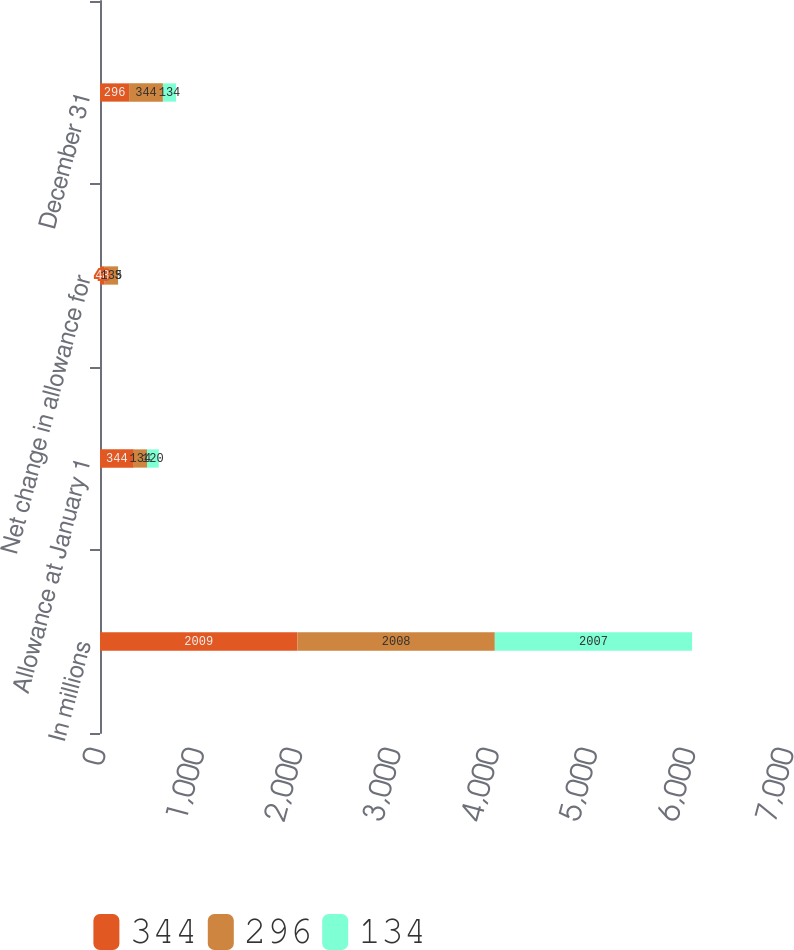<chart> <loc_0><loc_0><loc_500><loc_500><stacked_bar_chart><ecel><fcel>In millions<fcel>Allowance at January 1<fcel>Net change in allowance for<fcel>December 31<nl><fcel>344<fcel>2009<fcel>344<fcel>48<fcel>296<nl><fcel>296<fcel>2008<fcel>134<fcel>135<fcel>344<nl><fcel>134<fcel>2007<fcel>120<fcel>3<fcel>134<nl></chart> 